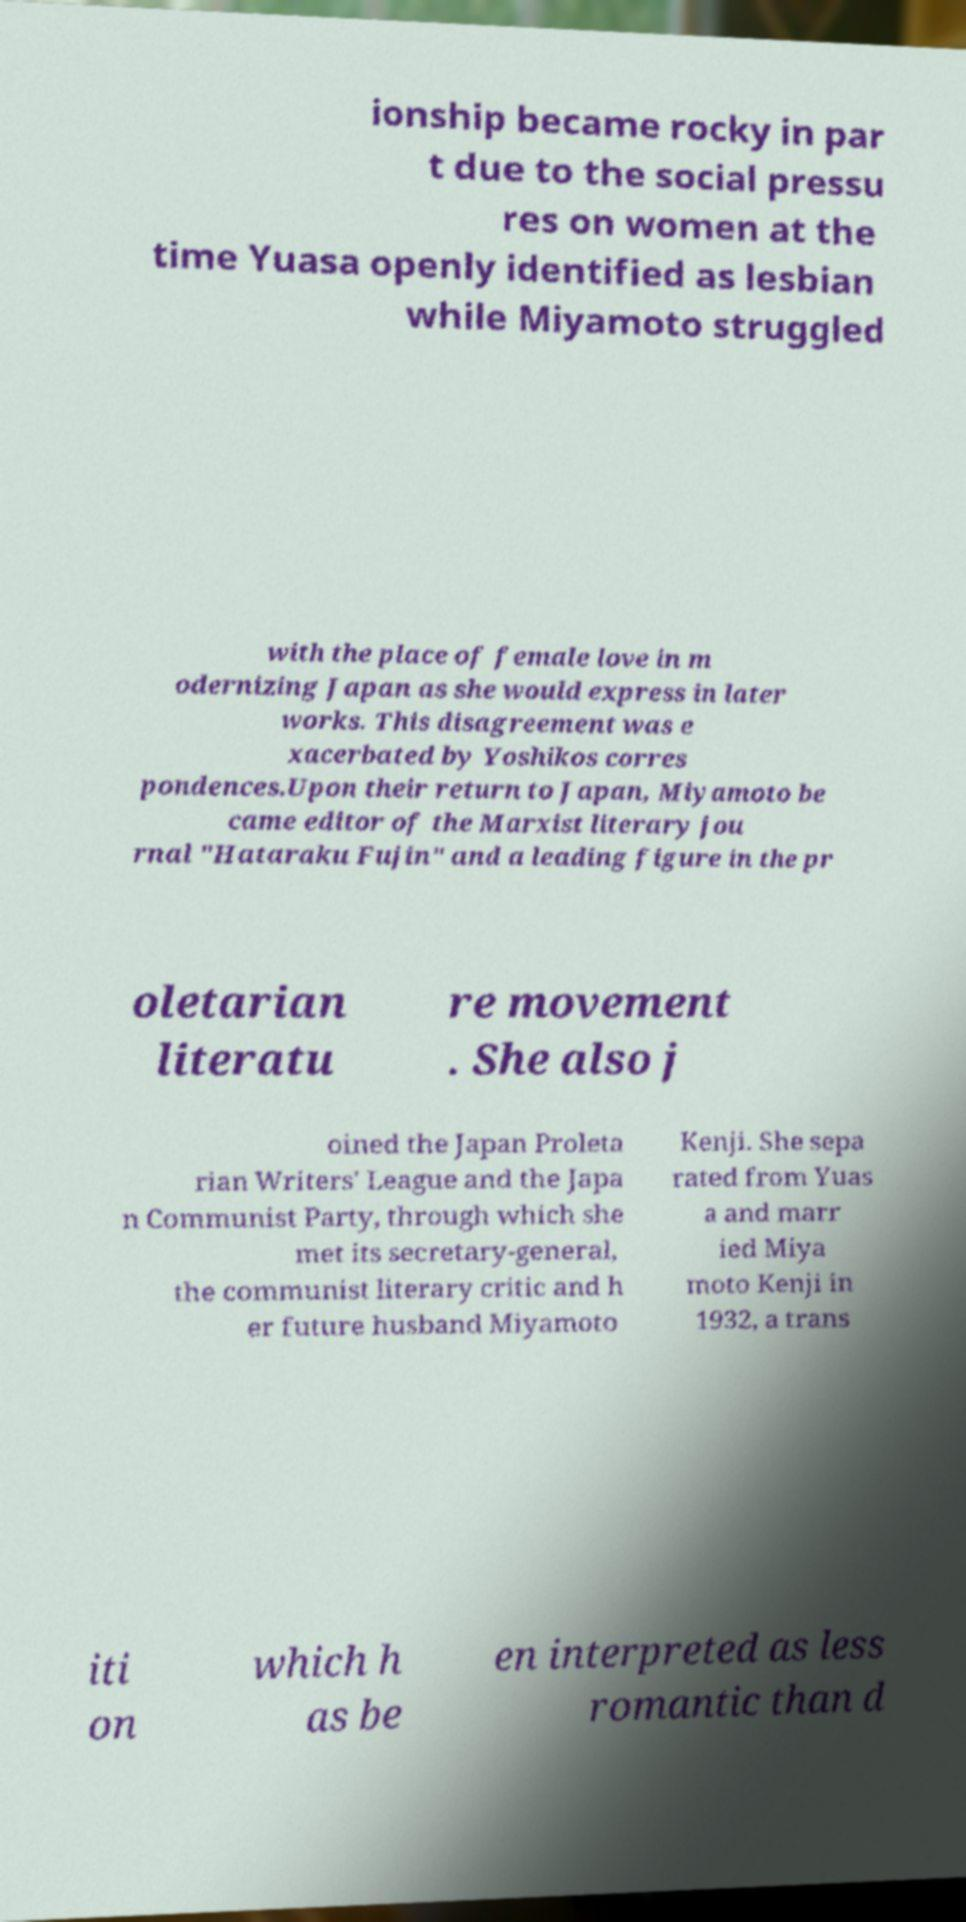Can you read and provide the text displayed in the image?This photo seems to have some interesting text. Can you extract and type it out for me? ionship became rocky in par t due to the social pressu res on women at the time Yuasa openly identified as lesbian while Miyamoto struggled with the place of female love in m odernizing Japan as she would express in later works. This disagreement was e xacerbated by Yoshikos corres pondences.Upon their return to Japan, Miyamoto be came editor of the Marxist literary jou rnal "Hataraku Fujin" and a leading figure in the pr oletarian literatu re movement . She also j oined the Japan Proleta rian Writers' League and the Japa n Communist Party, through which she met its secretary-general, the communist literary critic and h er future husband Miyamoto Kenji. She sepa rated from Yuas a and marr ied Miya moto Kenji in 1932, a trans iti on which h as be en interpreted as less romantic than d 